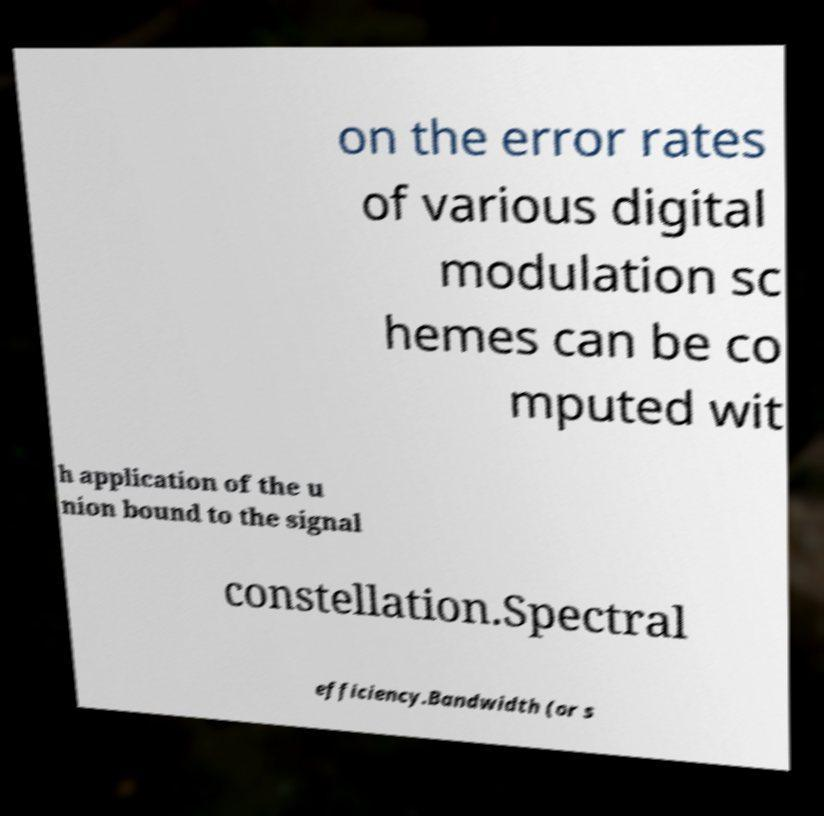Please identify and transcribe the text found in this image. on the error rates of various digital modulation sc hemes can be co mputed wit h application of the u nion bound to the signal constellation.Spectral efficiency.Bandwidth (or s 